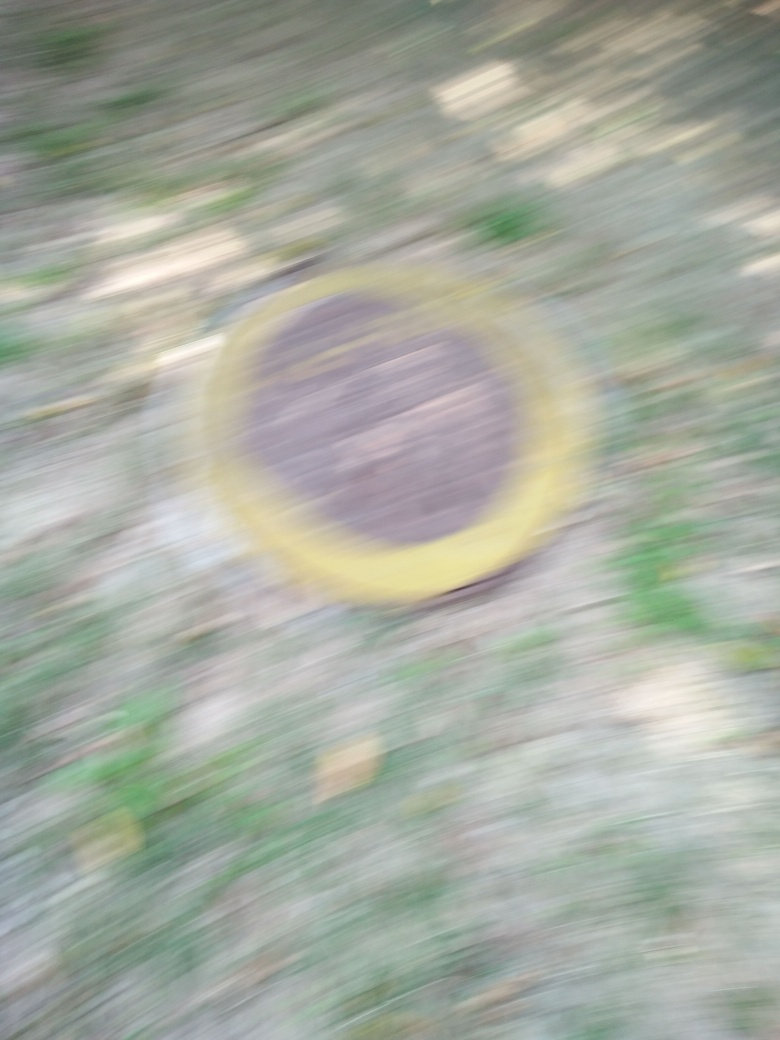If I wanted to interpret this image artistically, what could it represent? Artistically, this blurry image could convey a sense of haste or confusion. The circular shape, although indistinct, might represent continuity or wholeness. The blurring could also evoke feelings of nostalgia or loss, as details are lost much like distant memories. 